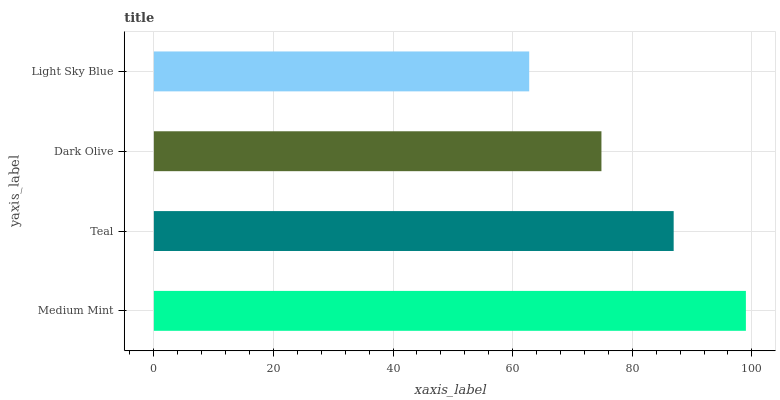Is Light Sky Blue the minimum?
Answer yes or no. Yes. Is Medium Mint the maximum?
Answer yes or no. Yes. Is Teal the minimum?
Answer yes or no. No. Is Teal the maximum?
Answer yes or no. No. Is Medium Mint greater than Teal?
Answer yes or no. Yes. Is Teal less than Medium Mint?
Answer yes or no. Yes. Is Teal greater than Medium Mint?
Answer yes or no. No. Is Medium Mint less than Teal?
Answer yes or no. No. Is Teal the high median?
Answer yes or no. Yes. Is Dark Olive the low median?
Answer yes or no. Yes. Is Light Sky Blue the high median?
Answer yes or no. No. Is Light Sky Blue the low median?
Answer yes or no. No. 